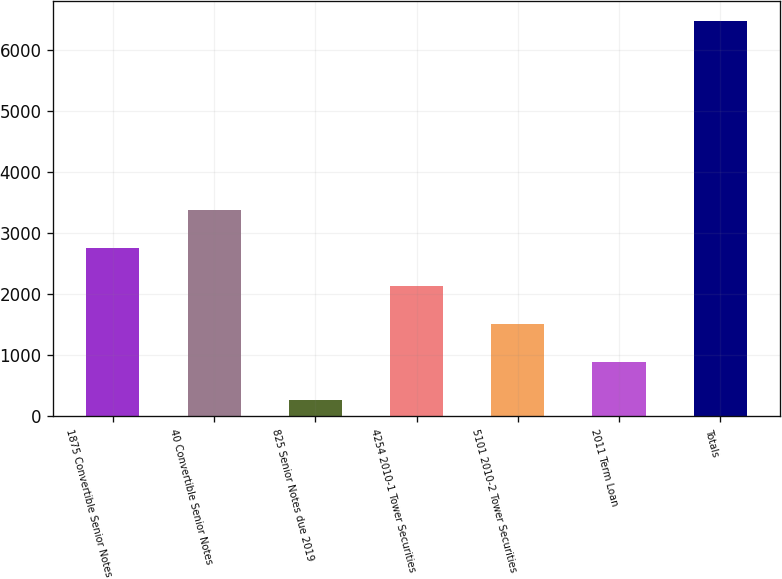Convert chart to OTSL. <chart><loc_0><loc_0><loc_500><loc_500><bar_chart><fcel>1875 Convertible Senior Notes<fcel>40 Convertible Senior Notes<fcel>825 Senior Notes due 2019<fcel>4254 2010-1 Tower Securities<fcel>5101 2010-2 Tower Securities<fcel>2011 Term Loan<fcel>Totals<nl><fcel>2754.84<fcel>3375.45<fcel>272.4<fcel>2134.23<fcel>1513.62<fcel>893.01<fcel>6478.5<nl></chart> 